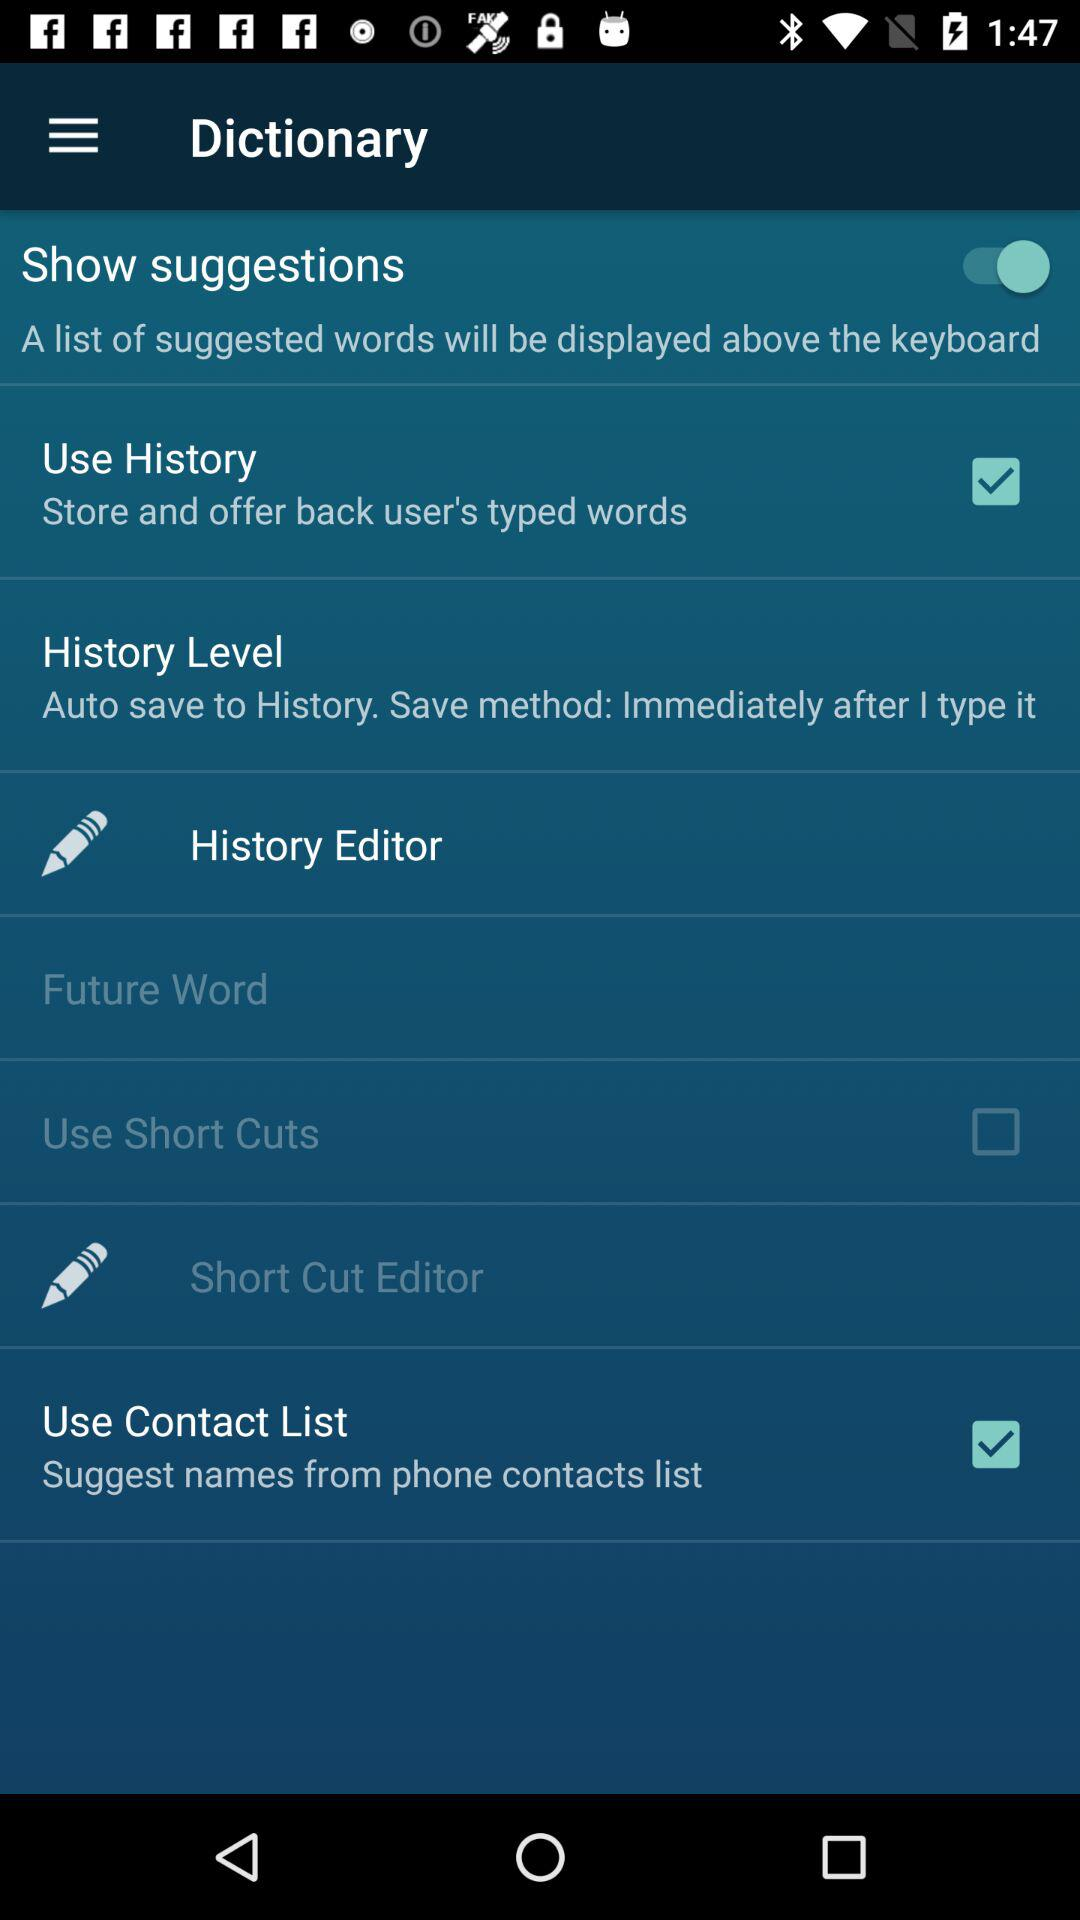What is the status of the "Use History"? The status is "on". 